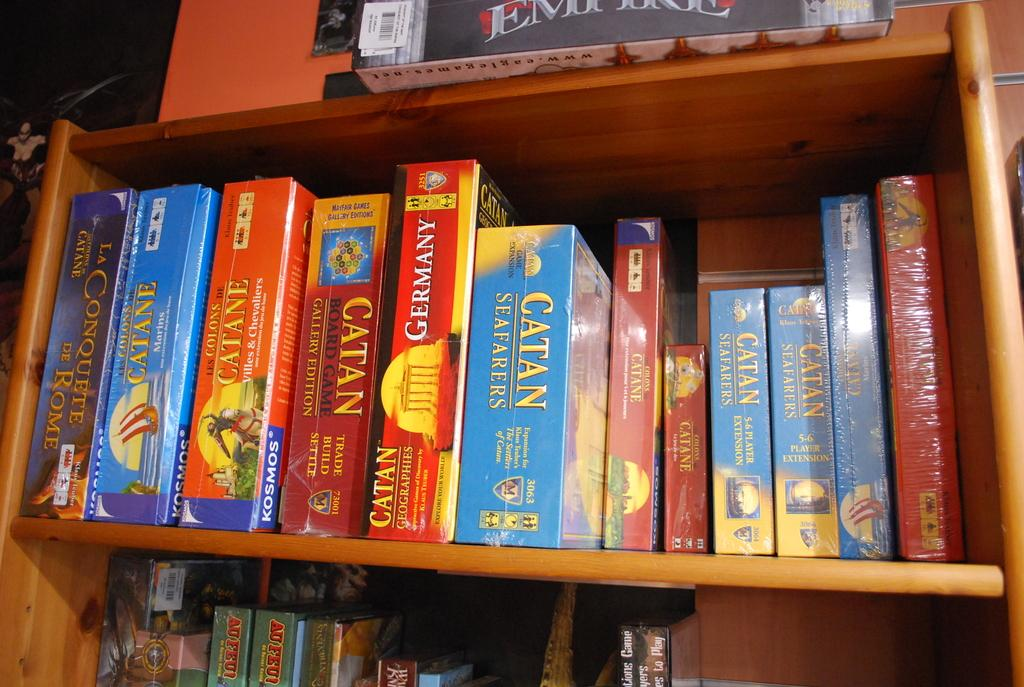<image>
Render a clear and concise summary of the photo. Various boxes labeled with Catan are arranged on a shelf. 